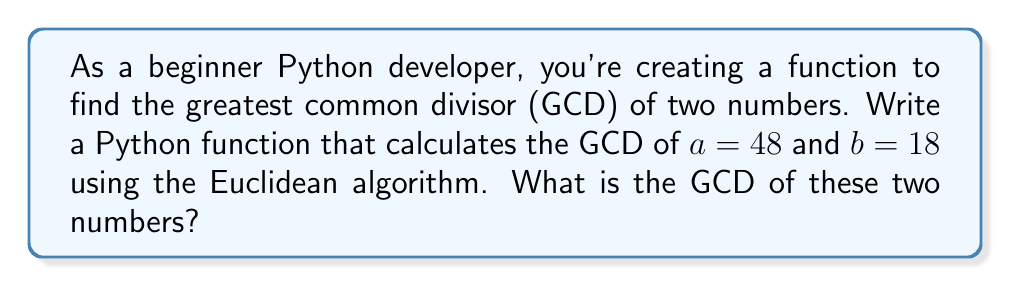Provide a solution to this math problem. To find the GCD using the Euclidean algorithm, we follow these steps:

1. Set $a = 48$ and $b = 18$.
2. Divide $a$ by $b$ and find the remainder:
   $48 = 2 \times 18 + 12$
3. If the remainder is 0, $b$ is the GCD. If not, set $a = b$ and $b = \text{remainder}$, then repeat step 2.
4. $a = 18$, $b = 12$
   $18 = 1 \times 12 + 6$
5. $a = 12$, $b = 6$
   $12 = 2 \times 6 + 0$

The process stops when the remainder is 0. The last non-zero remainder (6) is the GCD.

In Python, this algorithm can be implemented as:

```python
def gcd(a, b):
    while b != 0:
        a, b = b, a % b
    return a

print(gcd(48, 18))
```

This function will output 6, which is the GCD of 48 and 18.
Answer: 6 